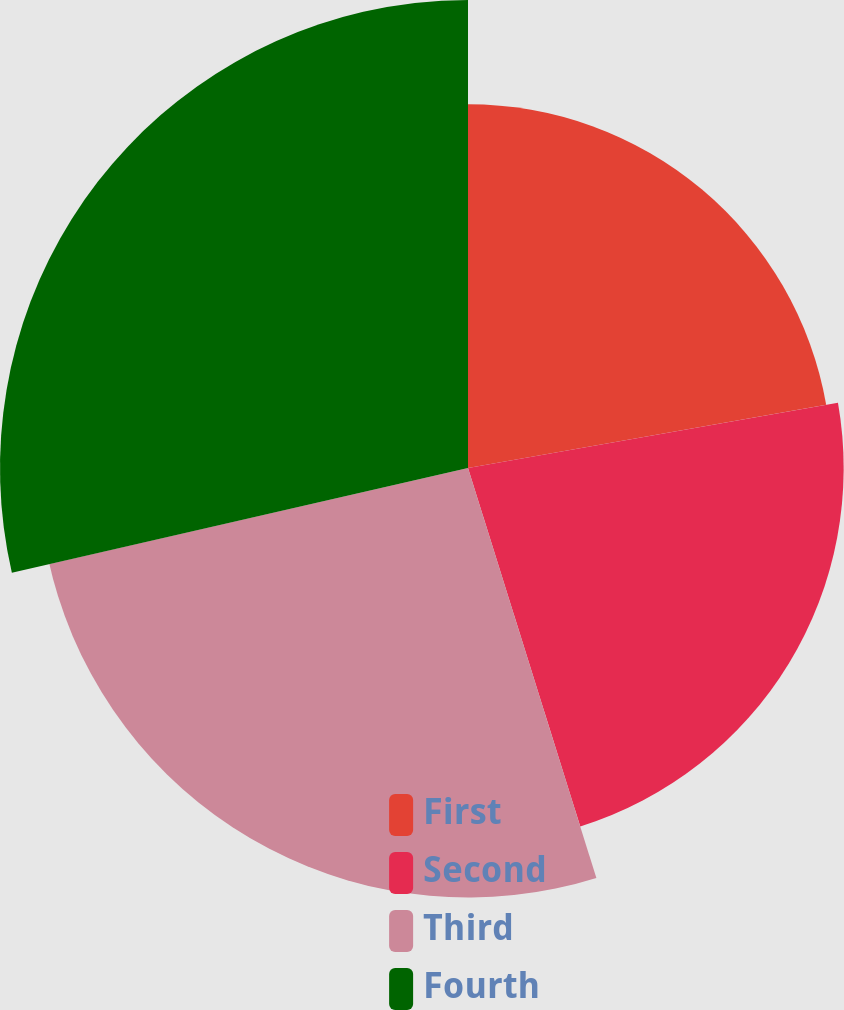Convert chart to OTSL. <chart><loc_0><loc_0><loc_500><loc_500><pie_chart><fcel>First<fcel>Second<fcel>Third<fcel>Fourth<nl><fcel>22.22%<fcel>22.95%<fcel>26.24%<fcel>28.59%<nl></chart> 